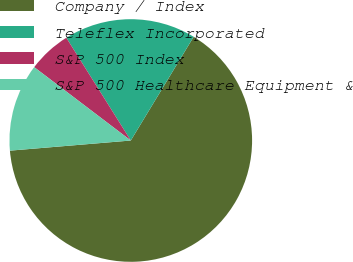<chart> <loc_0><loc_0><loc_500><loc_500><pie_chart><fcel>Company / Index<fcel>Teleflex Incorporated<fcel>S&P 500 Index<fcel>S&P 500 Healthcare Equipment &<nl><fcel>64.99%<fcel>17.59%<fcel>5.74%<fcel>11.67%<nl></chart> 